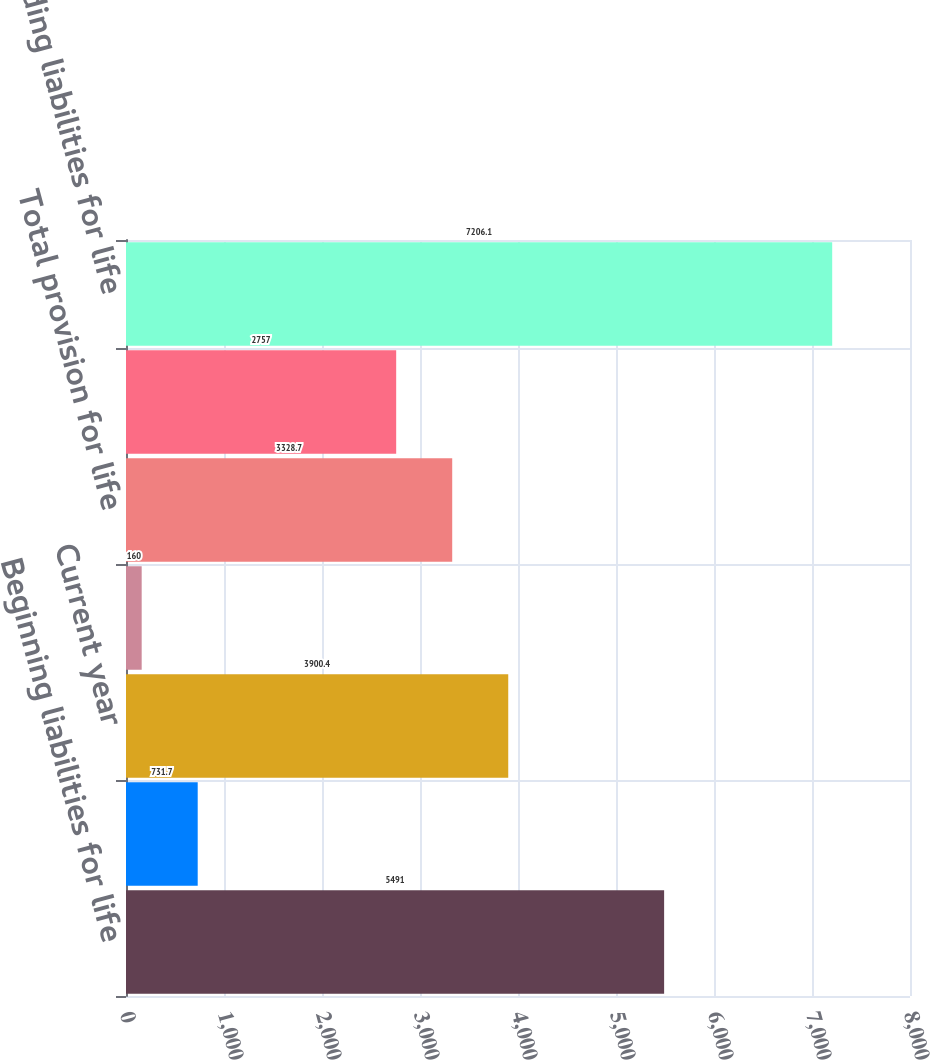Convert chart to OTSL. <chart><loc_0><loc_0><loc_500><loc_500><bar_chart><fcel>Beginning liabilities for life<fcel>Reinsurance recoverables<fcel>Current year<fcel>Prior years<fcel>Total provision for life<fcel>Total payments<fcel>Ending liabilities for life<nl><fcel>5491<fcel>731.7<fcel>3900.4<fcel>160<fcel>3328.7<fcel>2757<fcel>7206.1<nl></chart> 